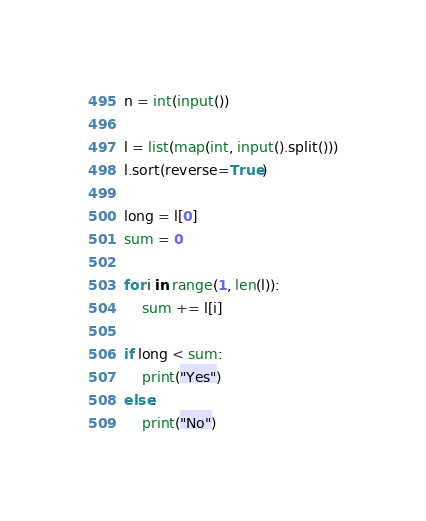<code> <loc_0><loc_0><loc_500><loc_500><_Python_>n = int(input())

l = list(map(int, input().split()))
l.sort(reverse=True)

long = l[0]
sum = 0

for i in range(1, len(l)):
    sum += l[i]

if long < sum:
    print("Yes")
else:
    print("No")</code> 